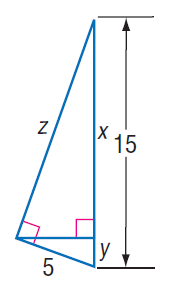Answer the mathemtical geometry problem and directly provide the correct option letter.
Question: Find y.
Choices: A: \frac { 3 } { 5 } B: \frac { 5 } { 3 } C: \frac { 5 } { \sqrt { 3 } } D: 5 B 